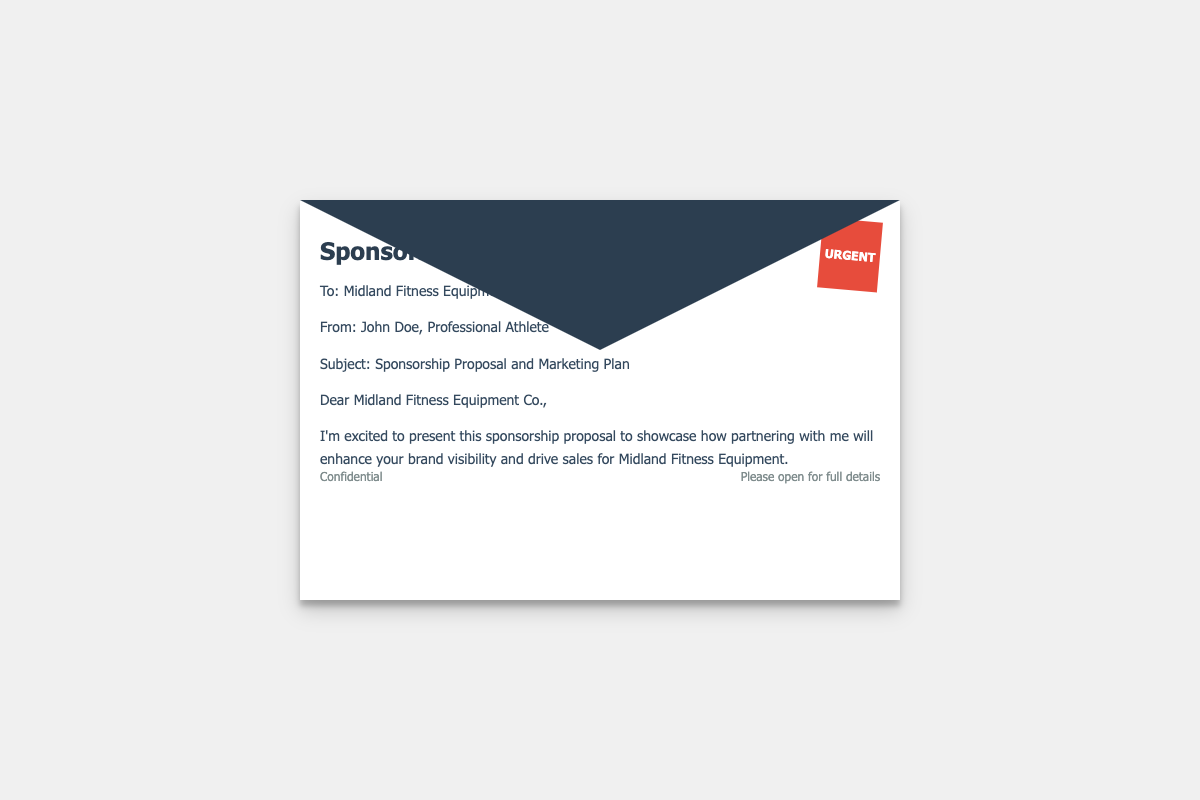What is the name of the fitness equipment manufacturer? The name of the fitness equipment manufacturer is located in the "To" section of the document.
Answer: Midland Fitness Equipment Co Who is the sender of the proposal? The sender of the proposal is identified in the "From" section of the document.
Answer: John Doe What is the subject of the proposal? The subject of the proposal is mentioned right after the sender's information.
Answer: Sponsorship Proposal and Marketing Plan What is the desired outcome of the partnership? The desired outcome is specified in the introductory paragraph of the content.
Answer: Enhance brand visibility and drive sales What type of document is this? The document is identified by its title at the top of the page.
Answer: Sponsorship Proposal What indicator shows the urgency of the proposal? The indicator of urgency is presented as a stamp on the envelope.
Answer: URGENT What is mentioned at the bottom of the envelope? The footer of the envelope contains confidentiality and opening instructions.
Answer: Confidential / Please open for full details What is the primary purpose of the proposal? The purpose of the proposal is outlined in the introductory statements.
Answer: Showcase partnership benefits What color scheme is used for the stamp? The stamp's color scheme is defined by its background and text color.
Answer: Red and white 